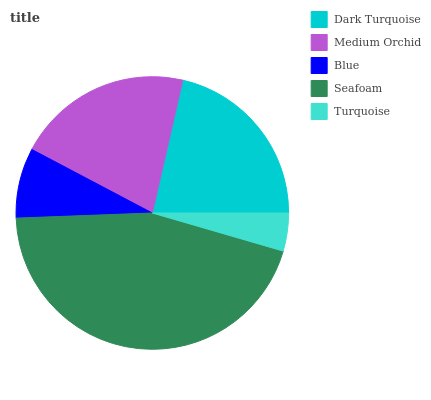Is Turquoise the minimum?
Answer yes or no. Yes. Is Seafoam the maximum?
Answer yes or no. Yes. Is Medium Orchid the minimum?
Answer yes or no. No. Is Medium Orchid the maximum?
Answer yes or no. No. Is Dark Turquoise greater than Medium Orchid?
Answer yes or no. Yes. Is Medium Orchid less than Dark Turquoise?
Answer yes or no. Yes. Is Medium Orchid greater than Dark Turquoise?
Answer yes or no. No. Is Dark Turquoise less than Medium Orchid?
Answer yes or no. No. Is Medium Orchid the high median?
Answer yes or no. Yes. Is Medium Orchid the low median?
Answer yes or no. Yes. Is Turquoise the high median?
Answer yes or no. No. Is Blue the low median?
Answer yes or no. No. 